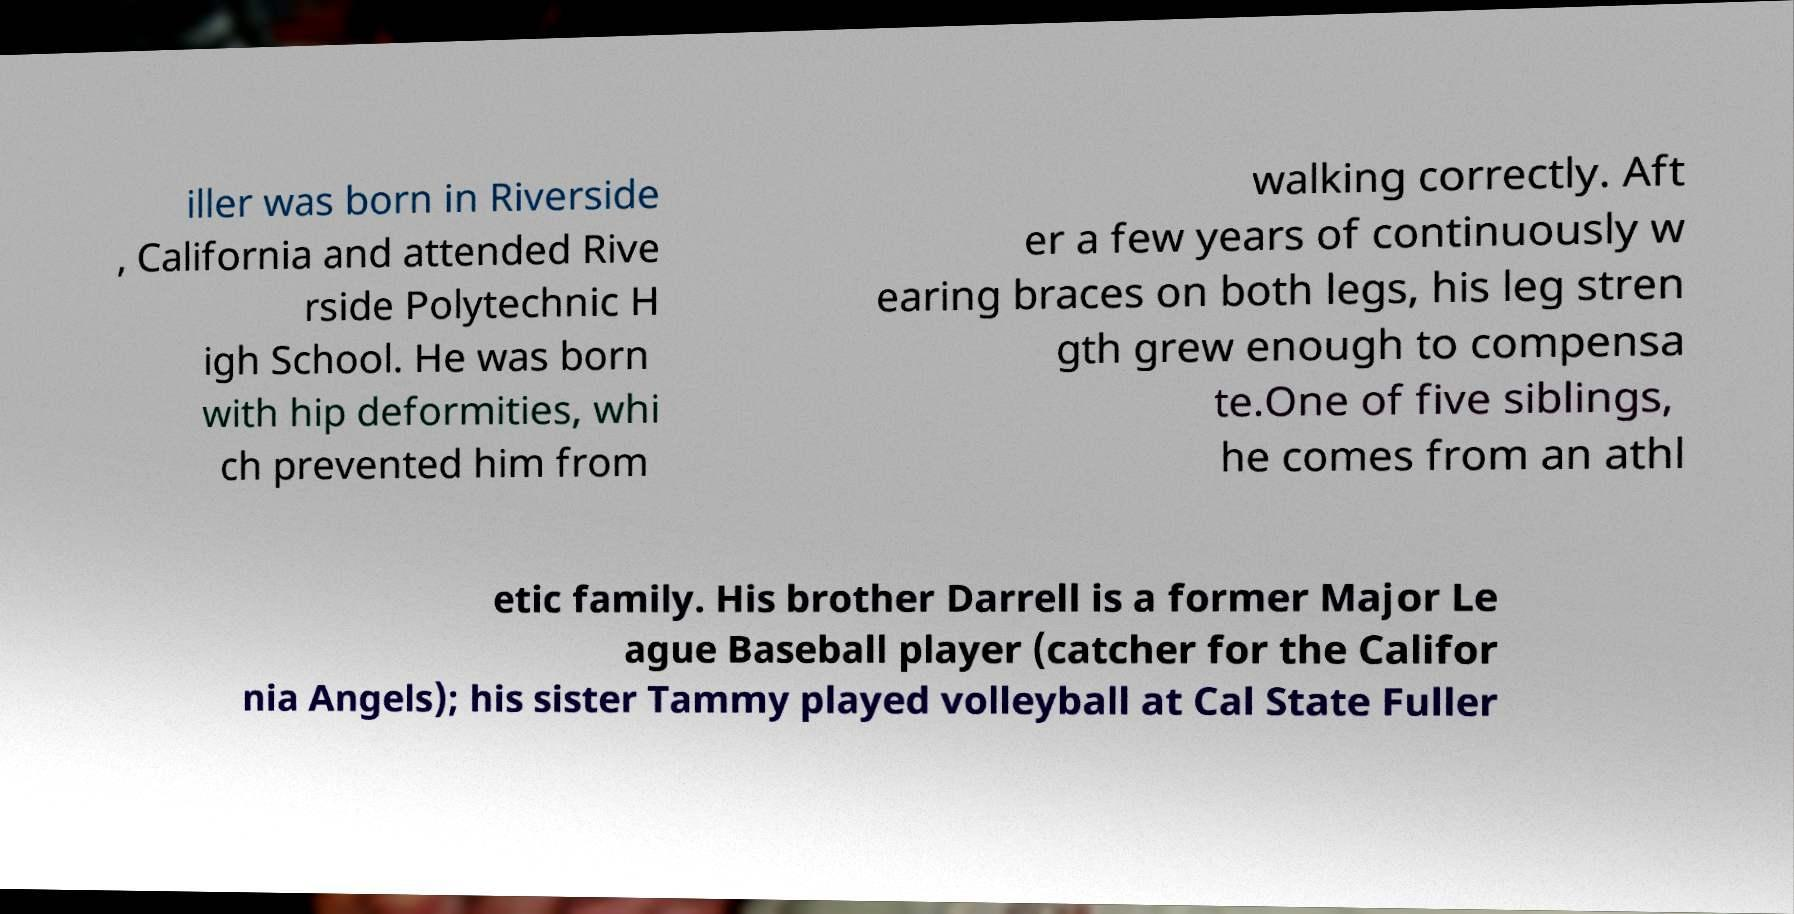Could you extract and type out the text from this image? iller was born in Riverside , California and attended Rive rside Polytechnic H igh School. He was born with hip deformities, whi ch prevented him from walking correctly. Aft er a few years of continuously w earing braces on both legs, his leg stren gth grew enough to compensa te.One of five siblings, he comes from an athl etic family. His brother Darrell is a former Major Le ague Baseball player (catcher for the Califor nia Angels); his sister Tammy played volleyball at Cal State Fuller 